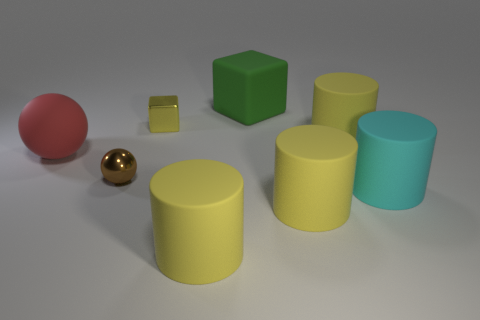Subtract all brown cubes. How many yellow cylinders are left? 3 Subtract all green cylinders. Subtract all yellow cubes. How many cylinders are left? 4 Add 2 red matte cylinders. How many objects exist? 10 Subtract all balls. How many objects are left? 6 Subtract all cyan spheres. Subtract all large green matte objects. How many objects are left? 7 Add 8 large red matte balls. How many large red matte balls are left? 9 Add 1 blue spheres. How many blue spheres exist? 1 Subtract 0 blue balls. How many objects are left? 8 